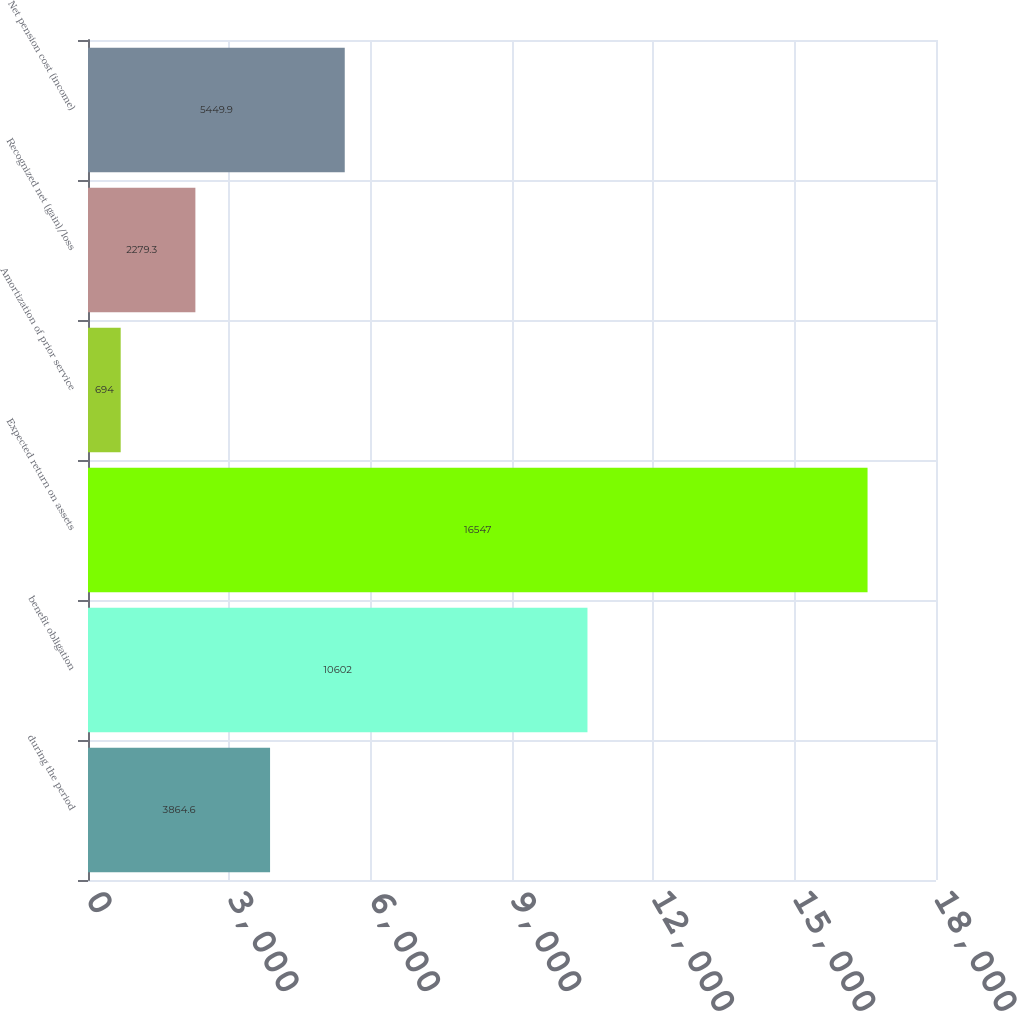Convert chart. <chart><loc_0><loc_0><loc_500><loc_500><bar_chart><fcel>during the period<fcel>benefit obligation<fcel>Expected return on assets<fcel>Amortization of prior service<fcel>Recognized net (gain)/loss<fcel>Net pension cost (income)<nl><fcel>3864.6<fcel>10602<fcel>16547<fcel>694<fcel>2279.3<fcel>5449.9<nl></chart> 